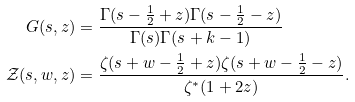<formula> <loc_0><loc_0><loc_500><loc_500>G ( s , z ) & = \frac { \Gamma ( s - \frac { 1 } { 2 } + z ) \Gamma ( s - \frac { 1 } { 2 } - z ) } { \Gamma ( s ) \Gamma ( s + k - 1 ) } \\ \mathcal { Z } ( s , w , z ) & = \frac { \zeta ( s + w - \frac { 1 } { 2 } + z ) \zeta ( s + w - \frac { 1 } { 2 } - z ) } { \zeta ^ { * } ( 1 + 2 z ) } .</formula> 